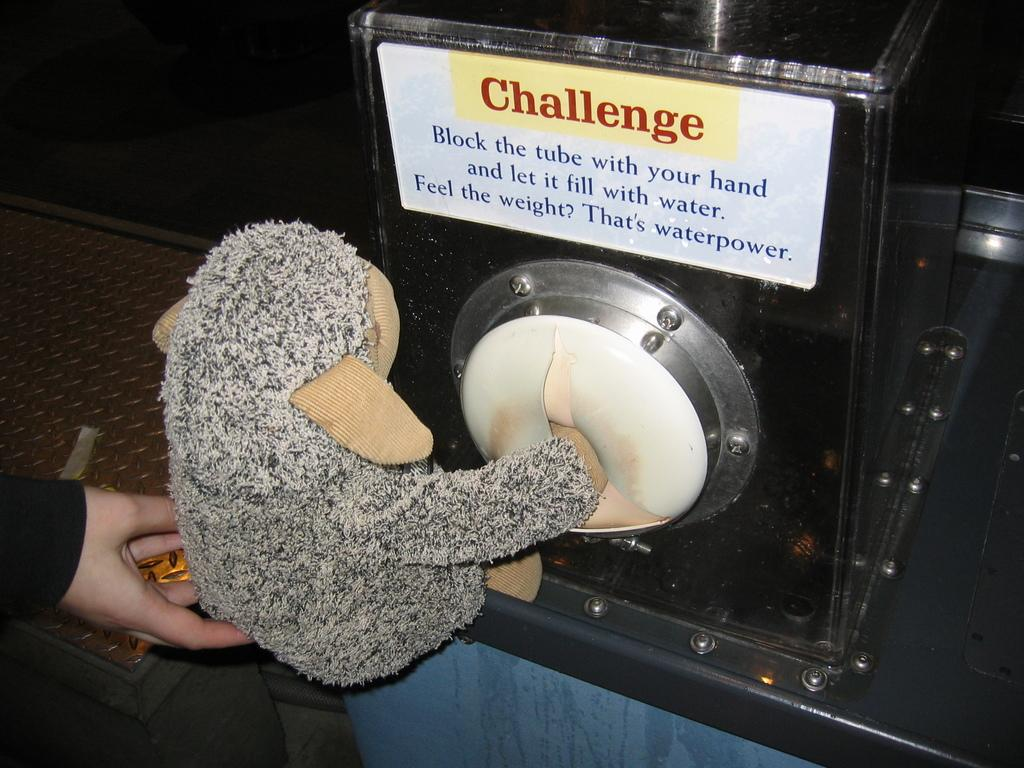What part of a person can be seen in the image? There is a person's hand in the image. What type of object is visible in the image? There is a toy in the image. What is on the box in the image? There is a sticker on the box in the image. What else can be seen in the image besides the hand, toy, and box? There are other objects in the image. How would you describe the lighting in the image? The background of the image is dark. What type of breakfast is being prepared in the image? There is no breakfast or any indication of food preparation in the image. How many lizards can be seen in the image? There are no lizards present in the image. 